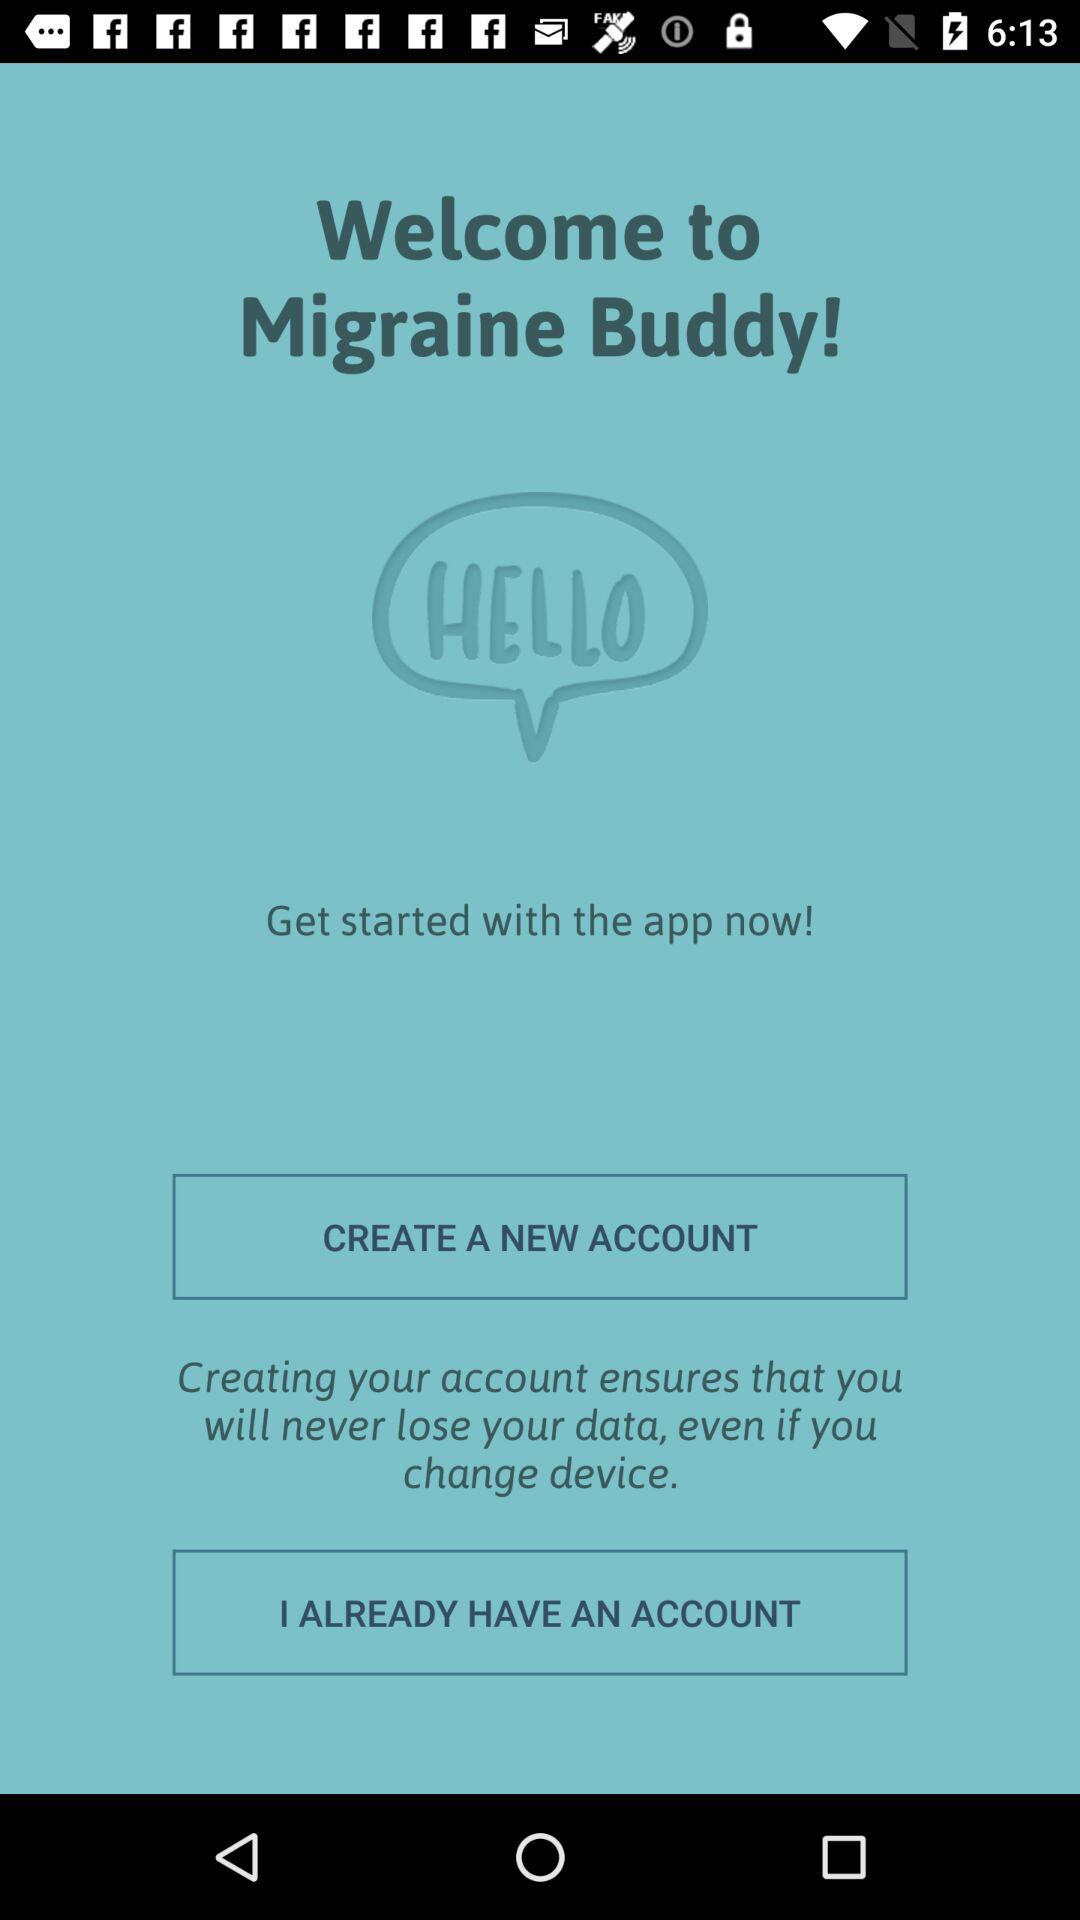What is the application name? The application name is "Migraine Buddy". 